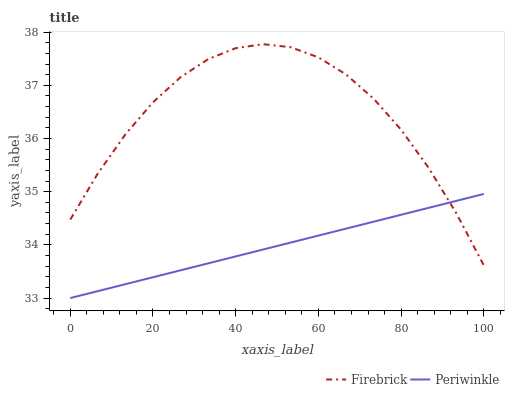Does Periwinkle have the minimum area under the curve?
Answer yes or no. Yes. Does Firebrick have the maximum area under the curve?
Answer yes or no. Yes. Does Periwinkle have the maximum area under the curve?
Answer yes or no. No. Is Periwinkle the smoothest?
Answer yes or no. Yes. Is Firebrick the roughest?
Answer yes or no. Yes. Is Periwinkle the roughest?
Answer yes or no. No. Does Periwinkle have the lowest value?
Answer yes or no. Yes. Does Firebrick have the highest value?
Answer yes or no. Yes. Does Periwinkle have the highest value?
Answer yes or no. No. Does Firebrick intersect Periwinkle?
Answer yes or no. Yes. Is Firebrick less than Periwinkle?
Answer yes or no. No. Is Firebrick greater than Periwinkle?
Answer yes or no. No. 